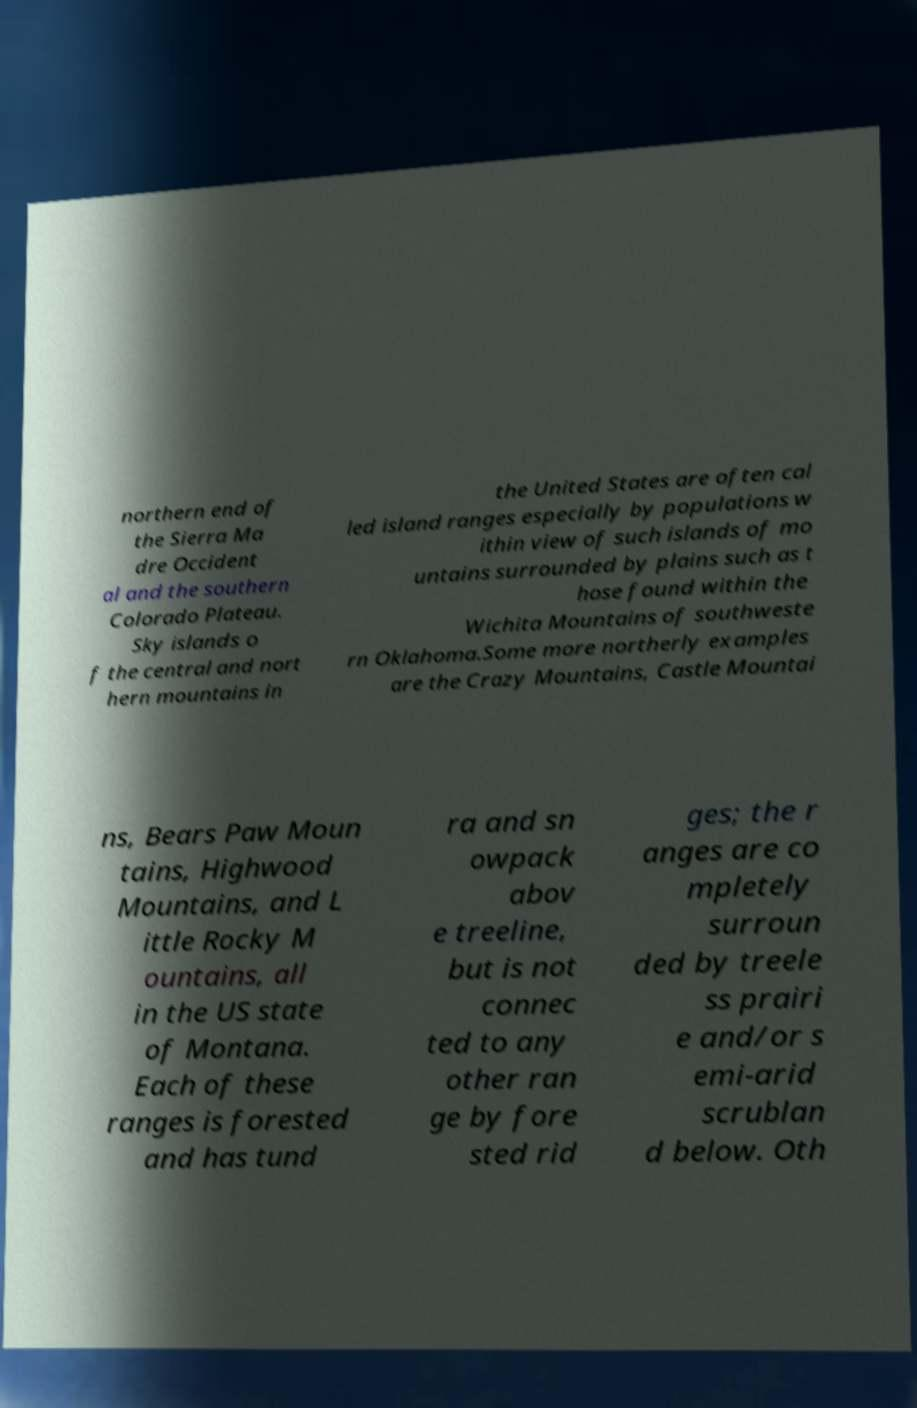Can you accurately transcribe the text from the provided image for me? northern end of the Sierra Ma dre Occident al and the southern Colorado Plateau. Sky islands o f the central and nort hern mountains in the United States are often cal led island ranges especially by populations w ithin view of such islands of mo untains surrounded by plains such as t hose found within the Wichita Mountains of southweste rn Oklahoma.Some more northerly examples are the Crazy Mountains, Castle Mountai ns, Bears Paw Moun tains, Highwood Mountains, and L ittle Rocky M ountains, all in the US state of Montana. Each of these ranges is forested and has tund ra and sn owpack abov e treeline, but is not connec ted to any other ran ge by fore sted rid ges; the r anges are co mpletely surroun ded by treele ss prairi e and/or s emi-arid scrublan d below. Oth 